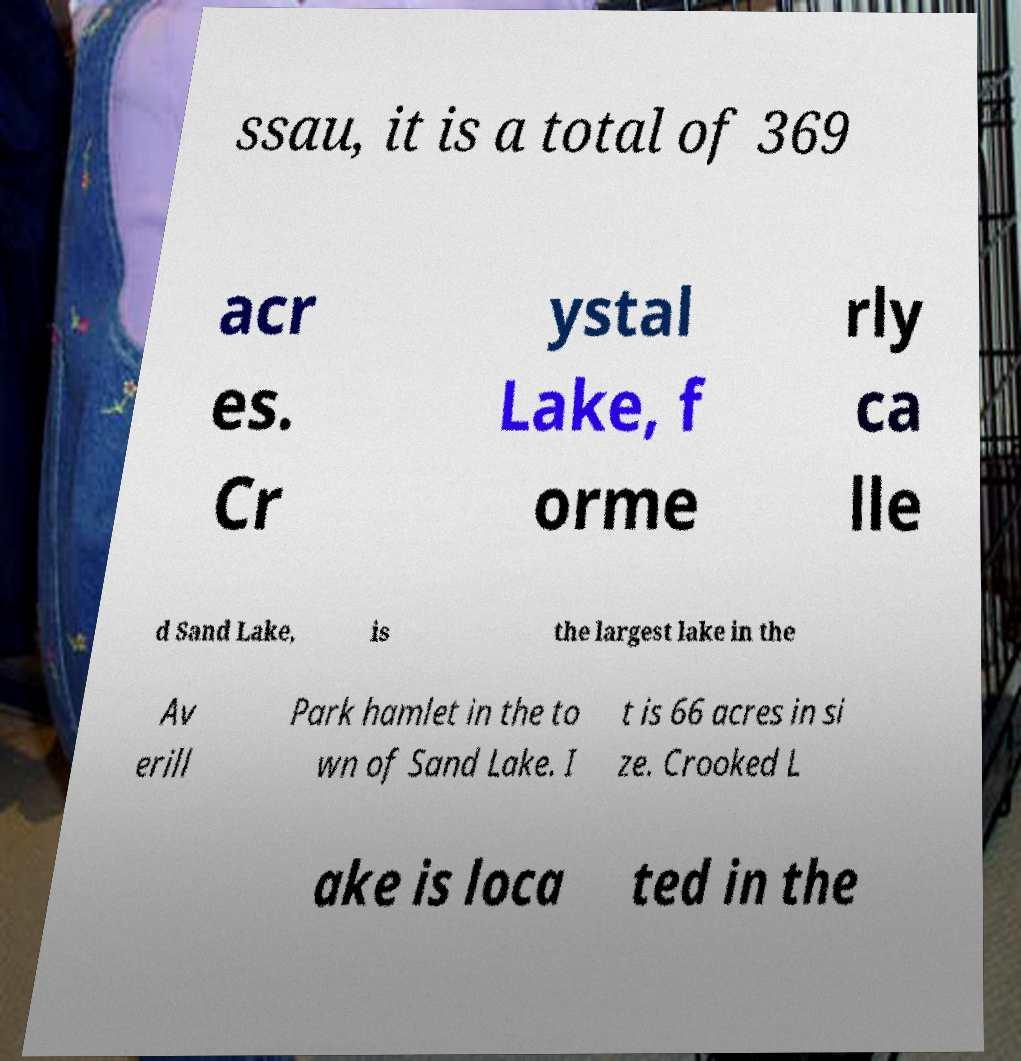I need the written content from this picture converted into text. Can you do that? ssau, it is a total of 369 acr es. Cr ystal Lake, f orme rly ca lle d Sand Lake, is the largest lake in the Av erill Park hamlet in the to wn of Sand Lake. I t is 66 acres in si ze. Crooked L ake is loca ted in the 